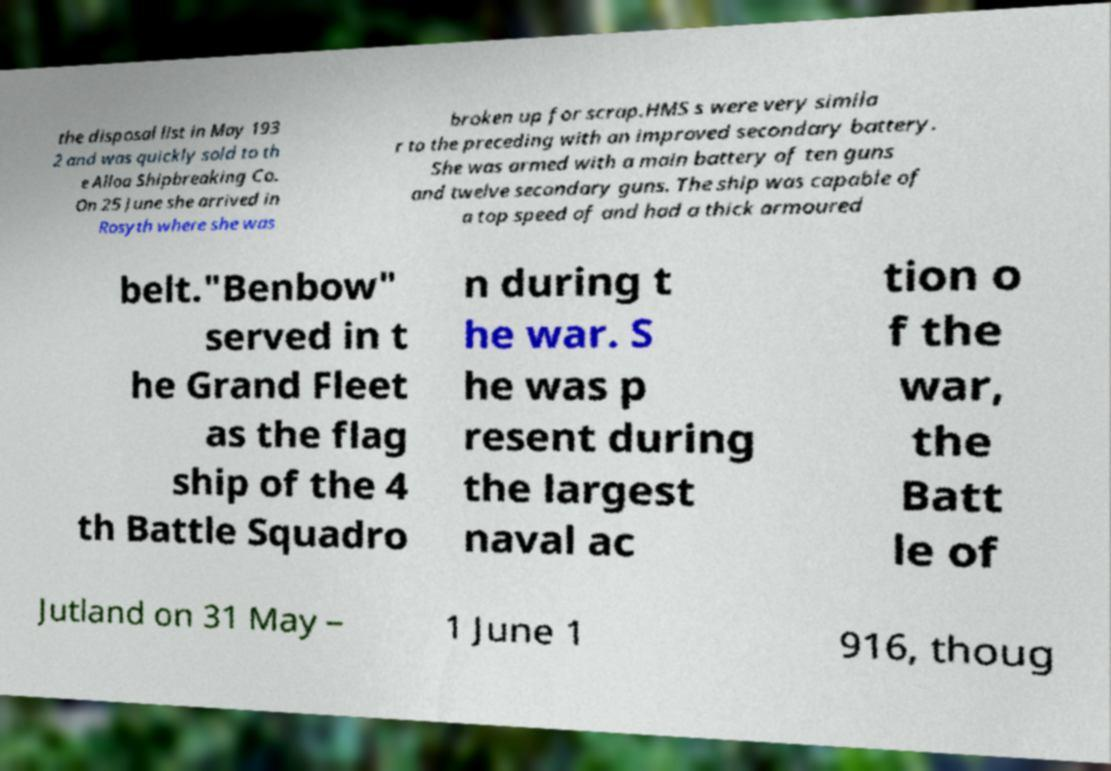There's text embedded in this image that I need extracted. Can you transcribe it verbatim? the disposal list in May 193 2 and was quickly sold to th e Alloa Shipbreaking Co. On 25 June she arrived in Rosyth where she was broken up for scrap.HMS s were very simila r to the preceding with an improved secondary battery. She was armed with a main battery of ten guns and twelve secondary guns. The ship was capable of a top speed of and had a thick armoured belt."Benbow" served in t he Grand Fleet as the flag ship of the 4 th Battle Squadro n during t he war. S he was p resent during the largest naval ac tion o f the war, the Batt le of Jutland on 31 May – 1 June 1 916, thoug 